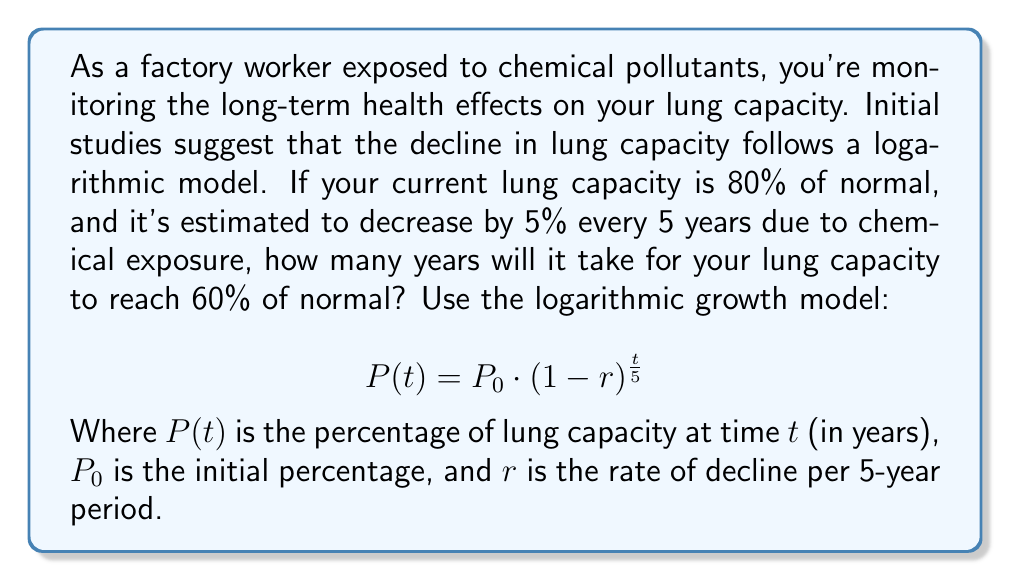Help me with this question. Let's approach this step-by-step:

1) We're given:
   $P_0 = 80\%$ (initial lung capacity)
   $r = 5\% = 0.05$ (rate of decline per 5 years)
   We need to find $t$ when $P(t) = 60\%$

2) Plug these into the logarithmic growth model:

   $$ 60 = 80 \cdot (1-0.05)^{\frac{t}{5}} $$

3) Simplify:

   $$ 0.75 = (0.95)^{\frac{t}{5}} $$

4) Take the natural log of both sides:

   $$ \ln(0.75) = \frac{t}{5} \ln(0.95) $$

5) Solve for $t$:

   $$ t = \frac{5 \ln(0.75)}{\ln(0.95)} $$

6) Calculate:

   $$ t = \frac{5 \cdot (-0.2876820724517809)}{-0.05129329438755058} $$
   $$ t \approx 28.02 \text{ years} $$

7) Since we're dealing with whole years, we round up to the nearest year.
Answer: It will take approximately 29 years for your lung capacity to reach 60% of normal. 